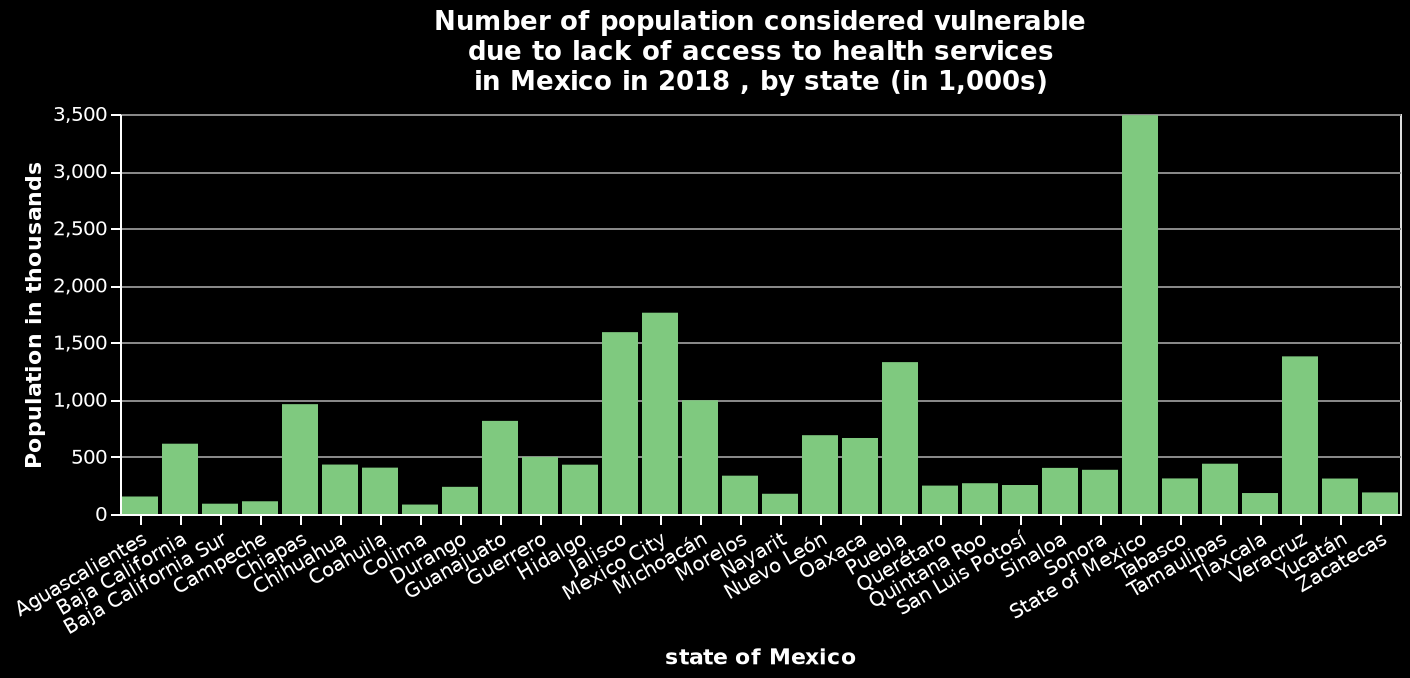<image>
How does the number of people considered vulnerable in the State of Mexico compare to Mexico City?  The number of people considered vulnerable in the State of Mexico is more than double than the number in Mexico City. 